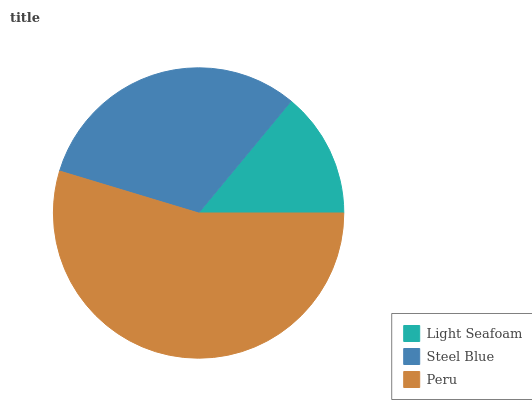Is Light Seafoam the minimum?
Answer yes or no. Yes. Is Peru the maximum?
Answer yes or no. Yes. Is Steel Blue the minimum?
Answer yes or no. No. Is Steel Blue the maximum?
Answer yes or no. No. Is Steel Blue greater than Light Seafoam?
Answer yes or no. Yes. Is Light Seafoam less than Steel Blue?
Answer yes or no. Yes. Is Light Seafoam greater than Steel Blue?
Answer yes or no. No. Is Steel Blue less than Light Seafoam?
Answer yes or no. No. Is Steel Blue the high median?
Answer yes or no. Yes. Is Steel Blue the low median?
Answer yes or no. Yes. Is Light Seafoam the high median?
Answer yes or no. No. Is Peru the low median?
Answer yes or no. No. 